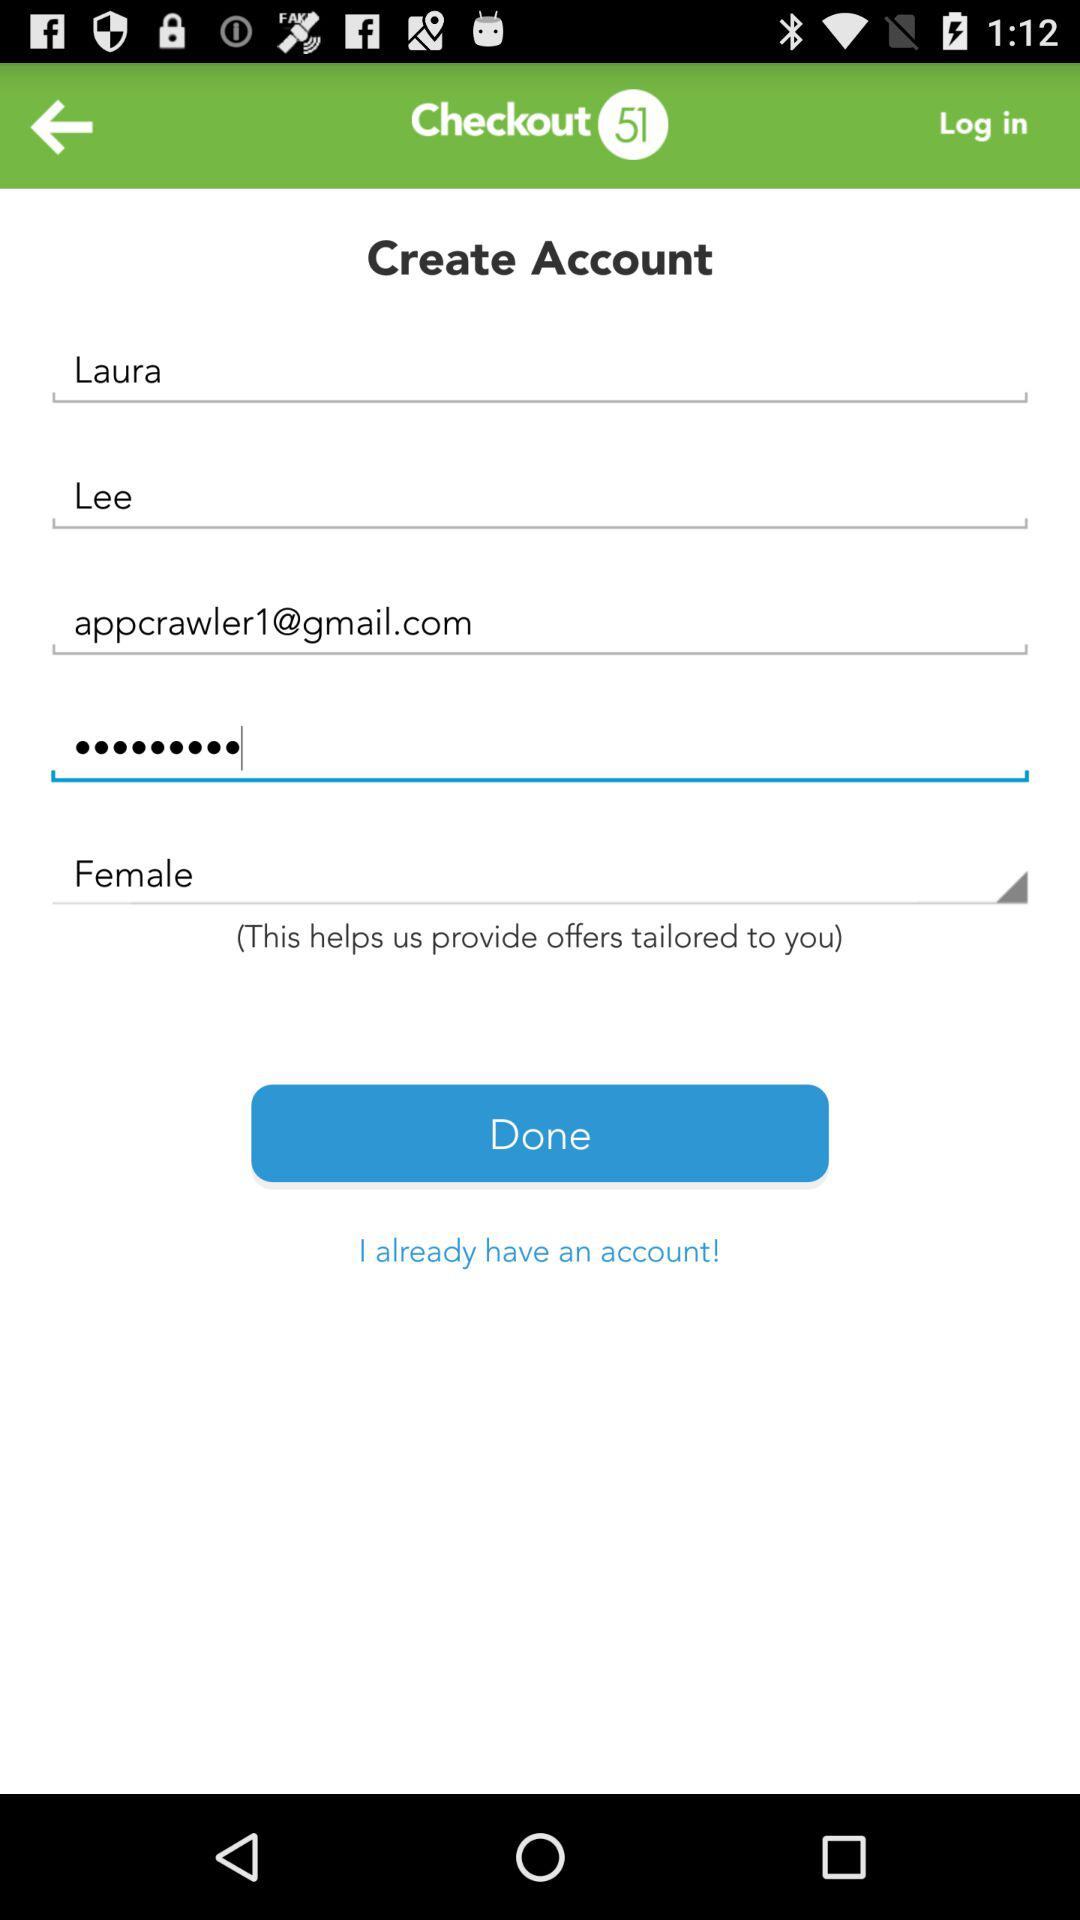What is the name of the application? The name of the application is "Checkout 51". 